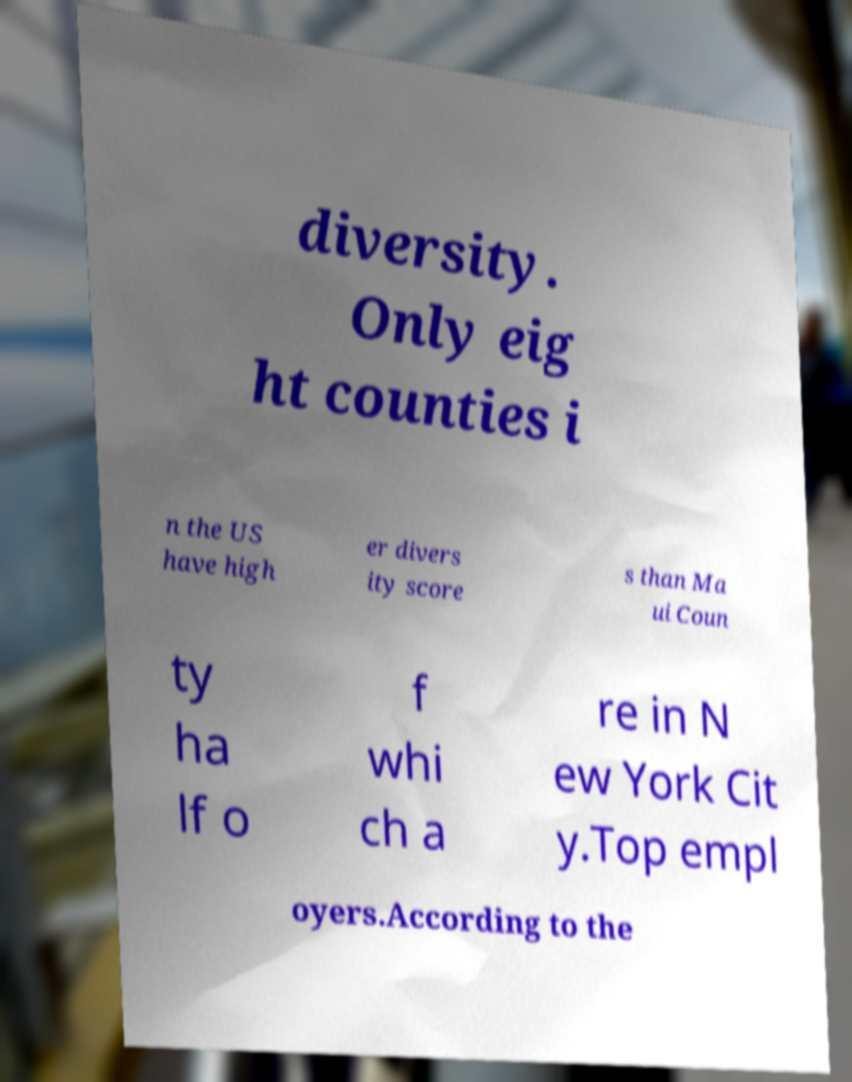Could you assist in decoding the text presented in this image and type it out clearly? diversity. Only eig ht counties i n the US have high er divers ity score s than Ma ui Coun ty ha lf o f whi ch a re in N ew York Cit y.Top empl oyers.According to the 